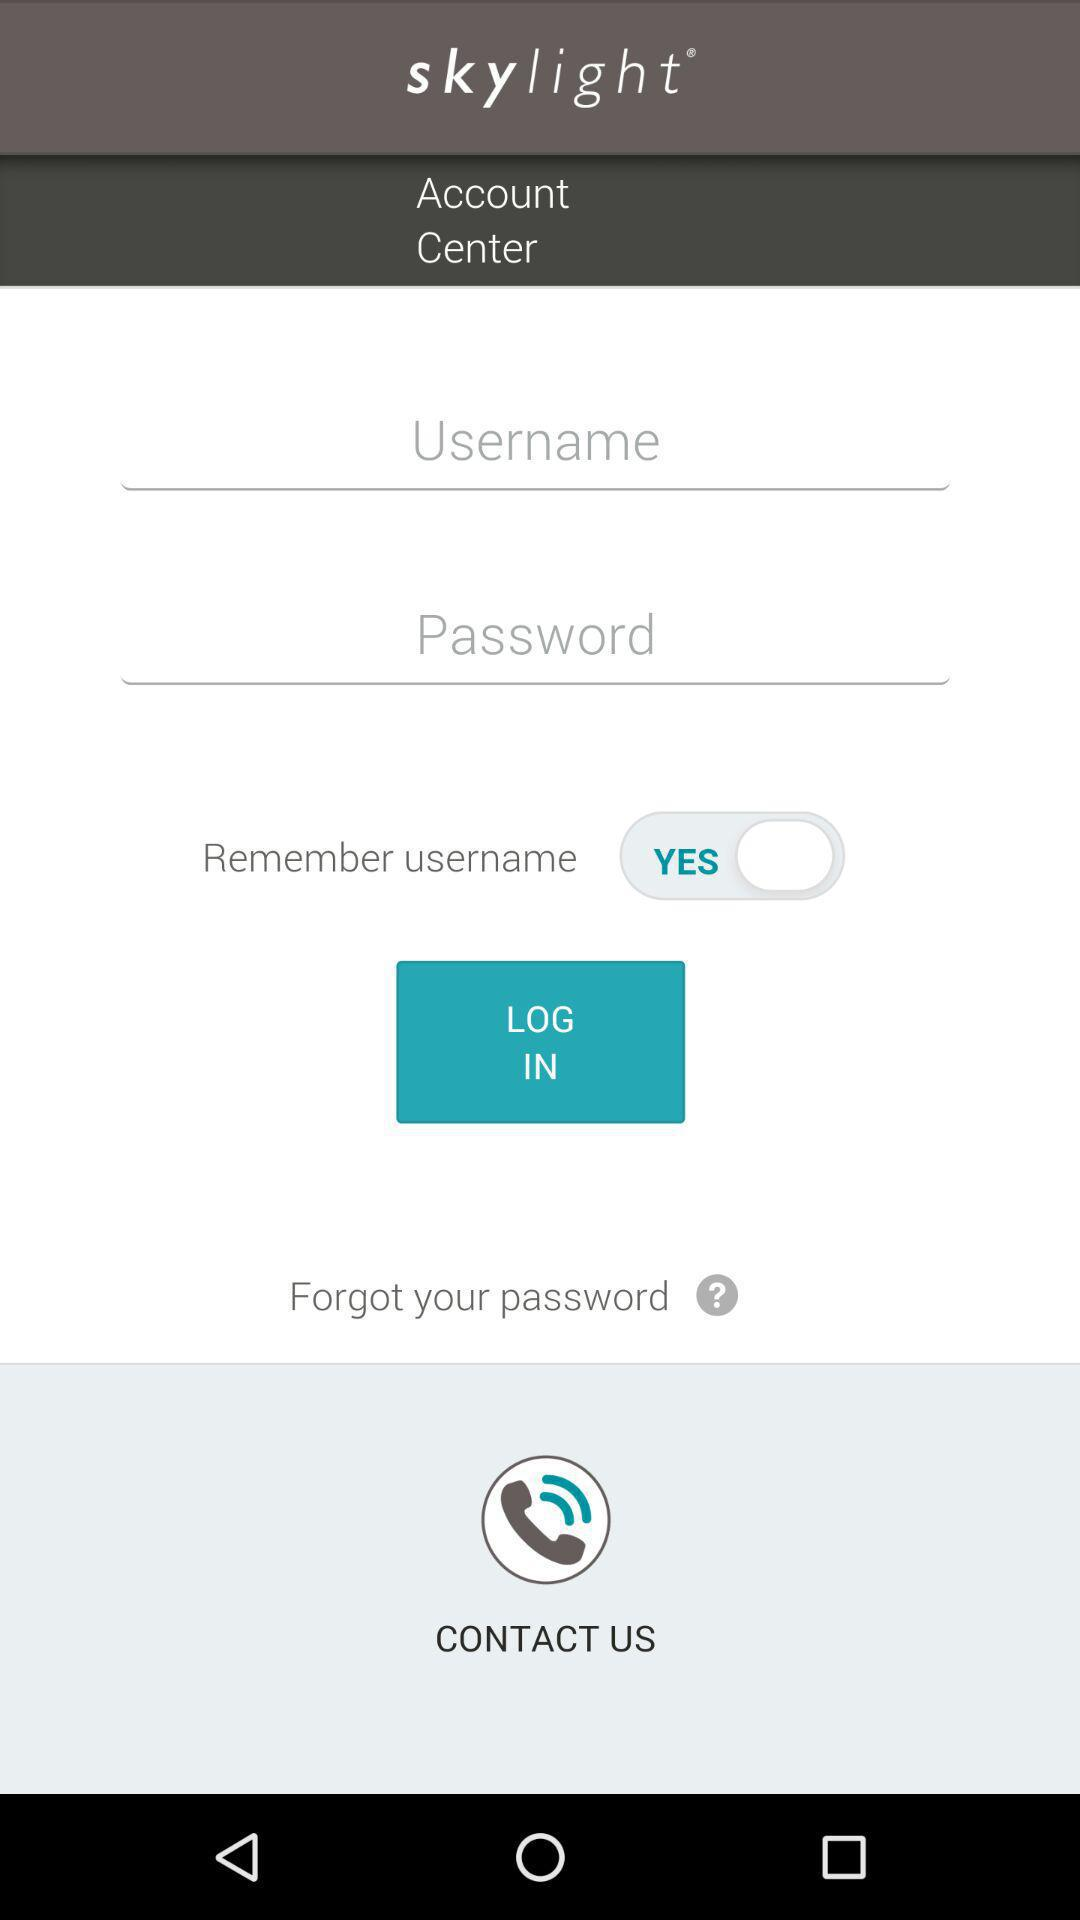How many text inputs are in this account center page?
Answer the question using a single word or phrase. 2 